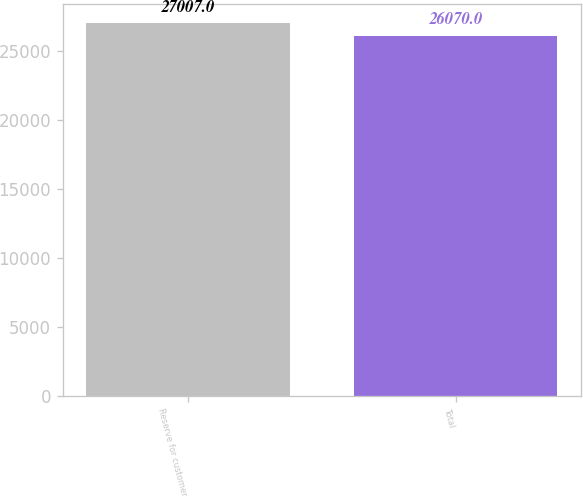<chart> <loc_0><loc_0><loc_500><loc_500><bar_chart><fcel>Reserve for customer<fcel>Total<nl><fcel>27007<fcel>26070<nl></chart> 